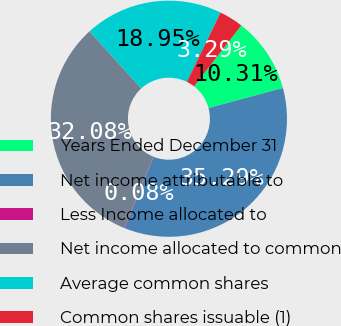Convert chart to OTSL. <chart><loc_0><loc_0><loc_500><loc_500><pie_chart><fcel>Years Ended December 31<fcel>Net income attributable to<fcel>Less Income allocated to<fcel>Net income allocated to common<fcel>Average common shares<fcel>Common shares issuable (1)<nl><fcel>10.31%<fcel>35.29%<fcel>0.08%<fcel>32.08%<fcel>18.95%<fcel>3.29%<nl></chart> 